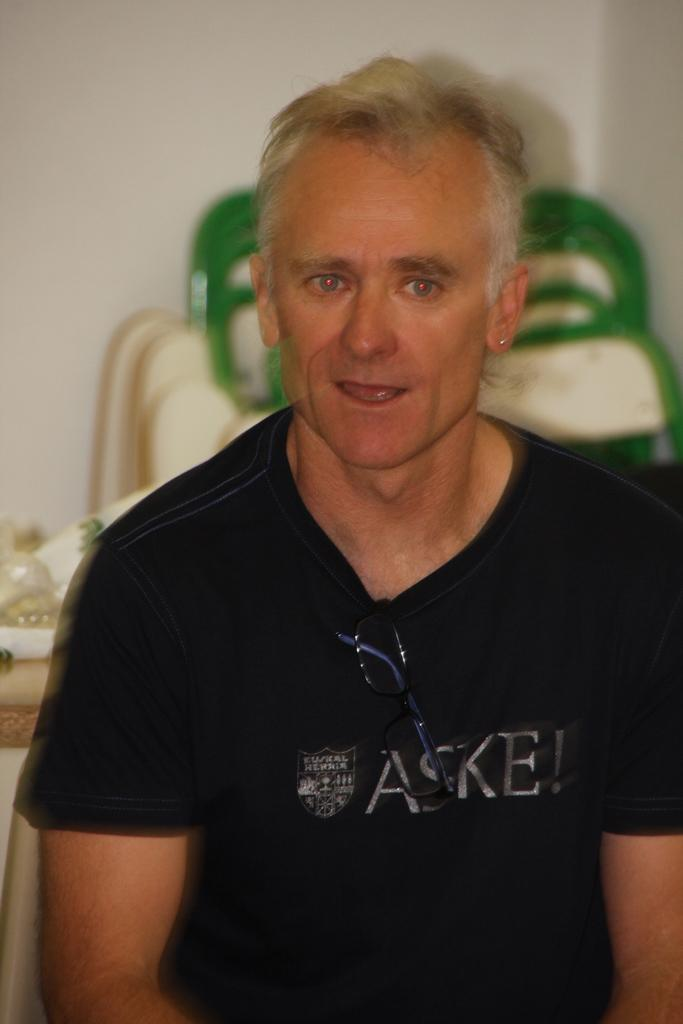What is the person in the image wearing? The person in the image is wearing a black t-shirt. What type of furniture can be seen in the image? Chairs are visible in the image. What is on the table in the image? There are objects on a table in the image. What is the background of the image? There is a wall in the image. How many eggs are on the wall in the image? There are no eggs present in the image; the wall is a background element. 